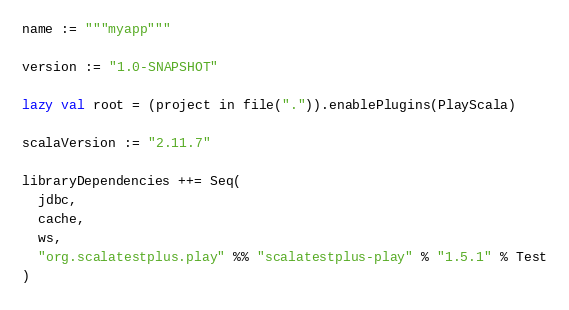<code> <loc_0><loc_0><loc_500><loc_500><_Scala_>name := """myapp"""

version := "1.0-SNAPSHOT"

lazy val root = (project in file(".")).enablePlugins(PlayScala)

scalaVersion := "2.11.7"

libraryDependencies ++= Seq(
  jdbc,
  cache,
  ws,
  "org.scalatestplus.play" %% "scalatestplus-play" % "1.5.1" % Test
)

</code> 